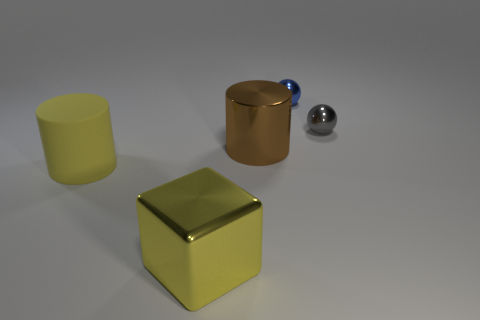Is there any other thing that is the same material as the big yellow cylinder?
Provide a short and direct response. No. What material is the tiny blue sphere?
Give a very brief answer. Metal. What number of cylinders are either big brown things or big yellow rubber things?
Offer a terse response. 2. Is the gray ball made of the same material as the yellow cylinder?
Your answer should be compact. No. What is the size of the other shiny object that is the same shape as the blue thing?
Ensure brevity in your answer.  Small. The thing that is both in front of the gray object and behind the big matte thing is made of what material?
Make the answer very short. Metal. Is the number of small blue things behind the shiny cylinder the same as the number of brown shiny cylinders?
Offer a very short reply. Yes. What number of things are cylinders to the left of the brown thing or tiny green blocks?
Give a very brief answer. 1. There is a big thing that is in front of the yellow rubber cylinder; is it the same color as the matte cylinder?
Keep it short and to the point. Yes. How big is the sphere to the right of the small blue sphere?
Your response must be concise. Small. 